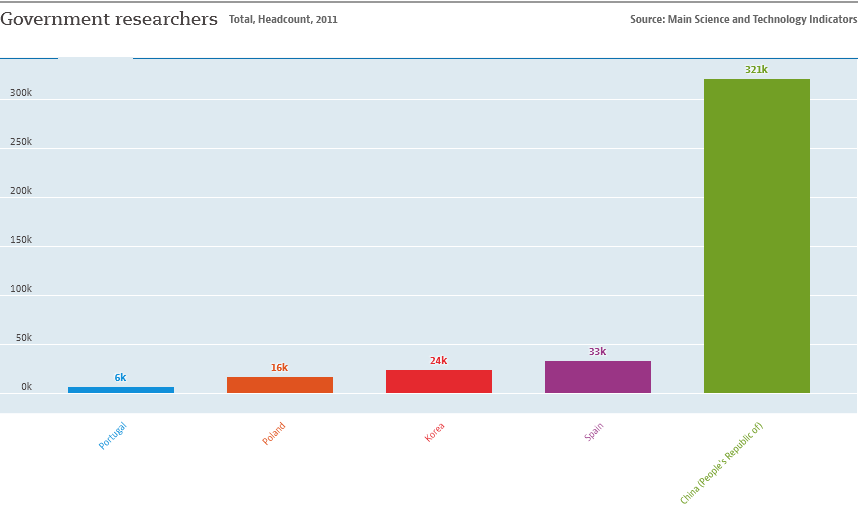Identify some key points in this picture. There are approximately three countries that have over 20,000 researchers. The purple bar represents Spain. 